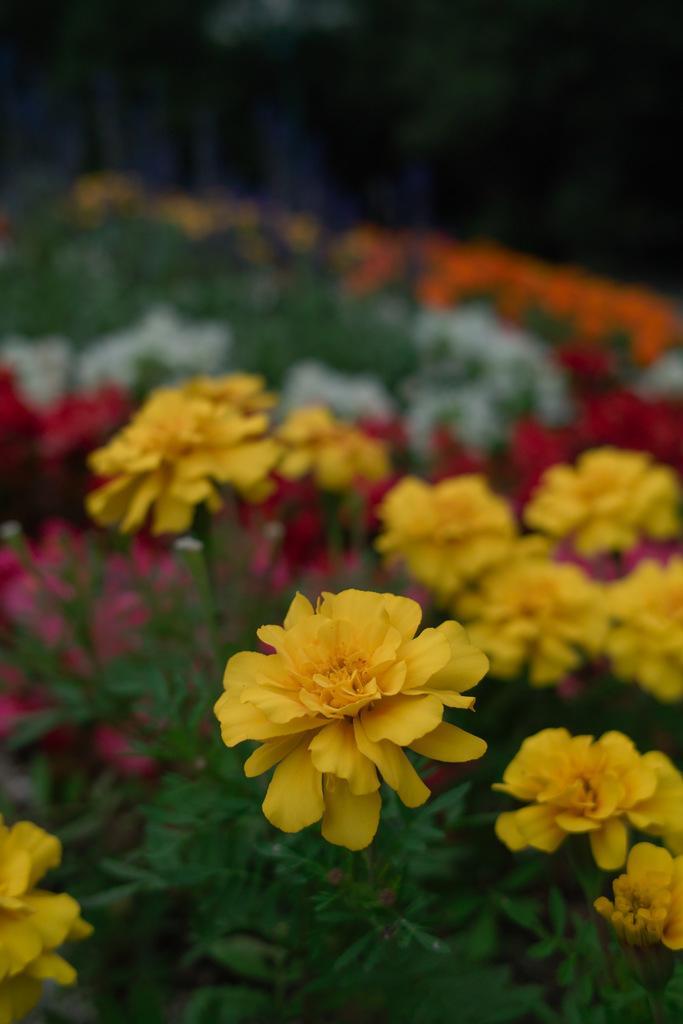Could you give a brief overview of what you see in this image? In this image there are plants, there are flowers, the top of the image is blurred. 